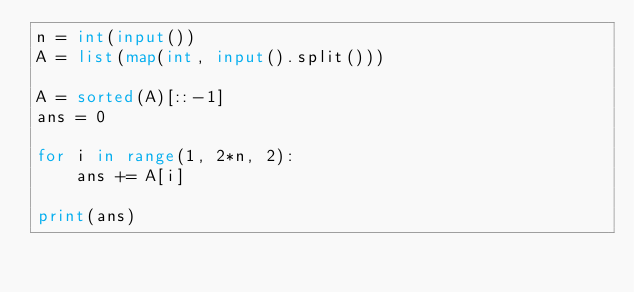Convert code to text. <code><loc_0><loc_0><loc_500><loc_500><_Python_>n = int(input())
A = list(map(int, input().split()))

A = sorted(A)[::-1]
ans = 0

for i in range(1, 2*n, 2):
    ans += A[i]

print(ans)
</code> 